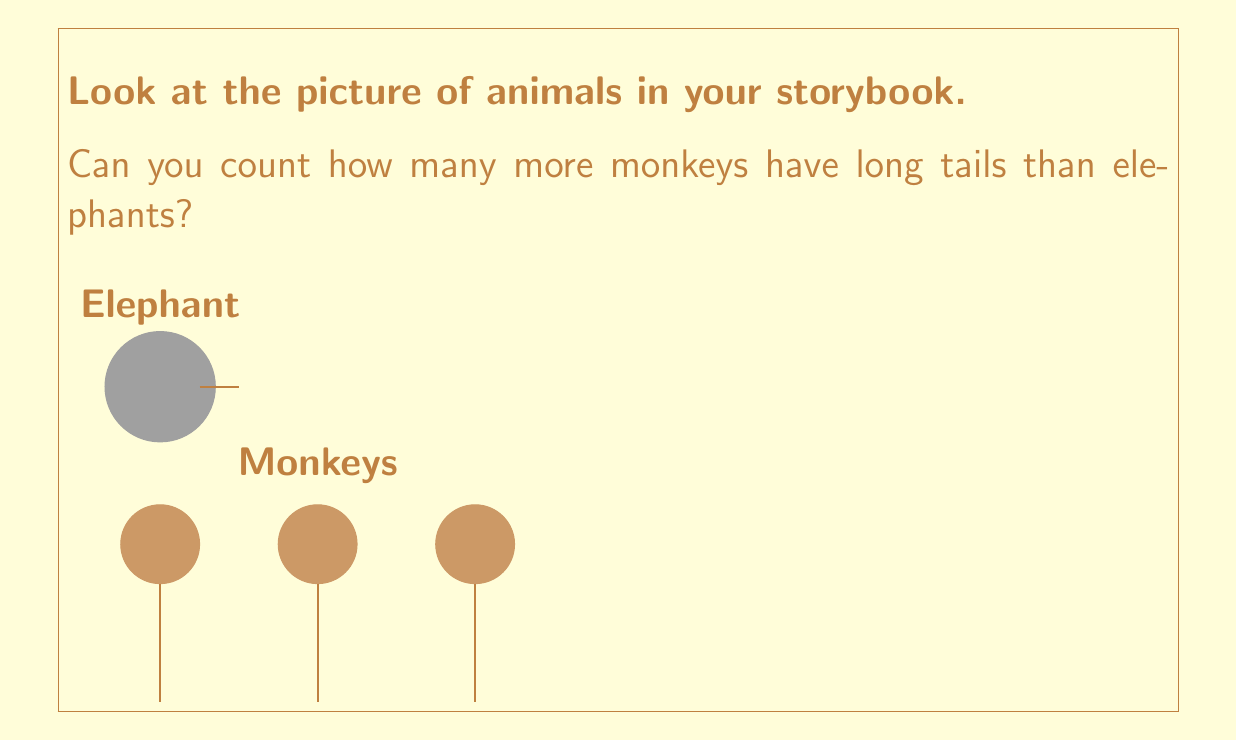Can you solve this math problem? Let's count together:

1. First, we count the monkeys with long tails:
   There are 3 monkeys with long tails.

2. Next, we count the elephants:
   There is 1 elephant with a short tail.

3. To find out how many more monkeys have long tails, we subtract:
   $3 - 1 = 2$

So, there are 2 more monkeys with long tails than elephants.
Answer: 2 